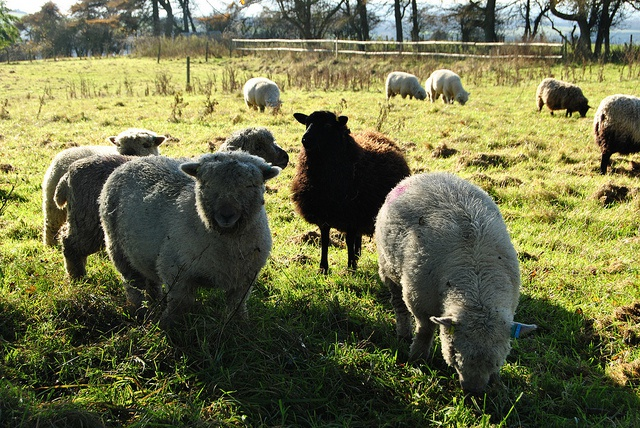Describe the objects in this image and their specific colors. I can see sheep in lightgray, black, gray, darkgray, and beige tones, sheep in lightgray, black, gray, and purple tones, sheep in lightgray, black, khaki, maroon, and tan tones, sheep in lightgray, black, gray, darkgray, and beige tones, and sheep in lightgray, ivory, black, darkgreen, and khaki tones in this image. 